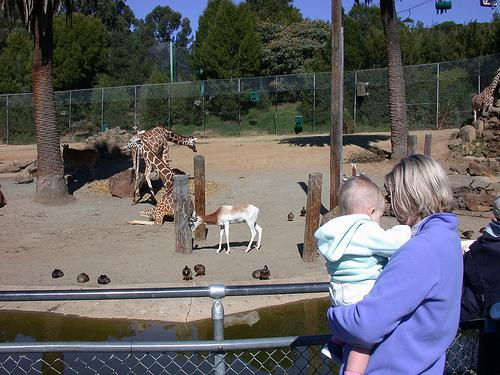Question: what is green?
Choices:
A. Trees.
B. Grass.
C. Bushes.
D. Leaves.
Answer with the letter. Answer: A Question: where was the picture taken?
Choices:
A. At a zoo.
B. At a park.
C. In a field.
D. At an animal park.
Answer with the letter. Answer: A Question: when was the photo taken?
Choices:
A. Nighttime.
B. Morning.
C. Afternoon.
D. Daytime.
Answer with the letter. Answer: D Question: what is purple?
Choices:
A. Woman's hat.
B. Shoes.
C. Woman's coat.
D. Pants.
Answer with the letter. Answer: C Question: who is wearing white?
Choices:
A. Boy.
B. Girl.
C. A baby.
D. Woman.
Answer with the letter. Answer: C Question: how many giraffe are there?
Choices:
A. One.
B. Two.
C. Three.
D. None.
Answer with the letter. Answer: B 